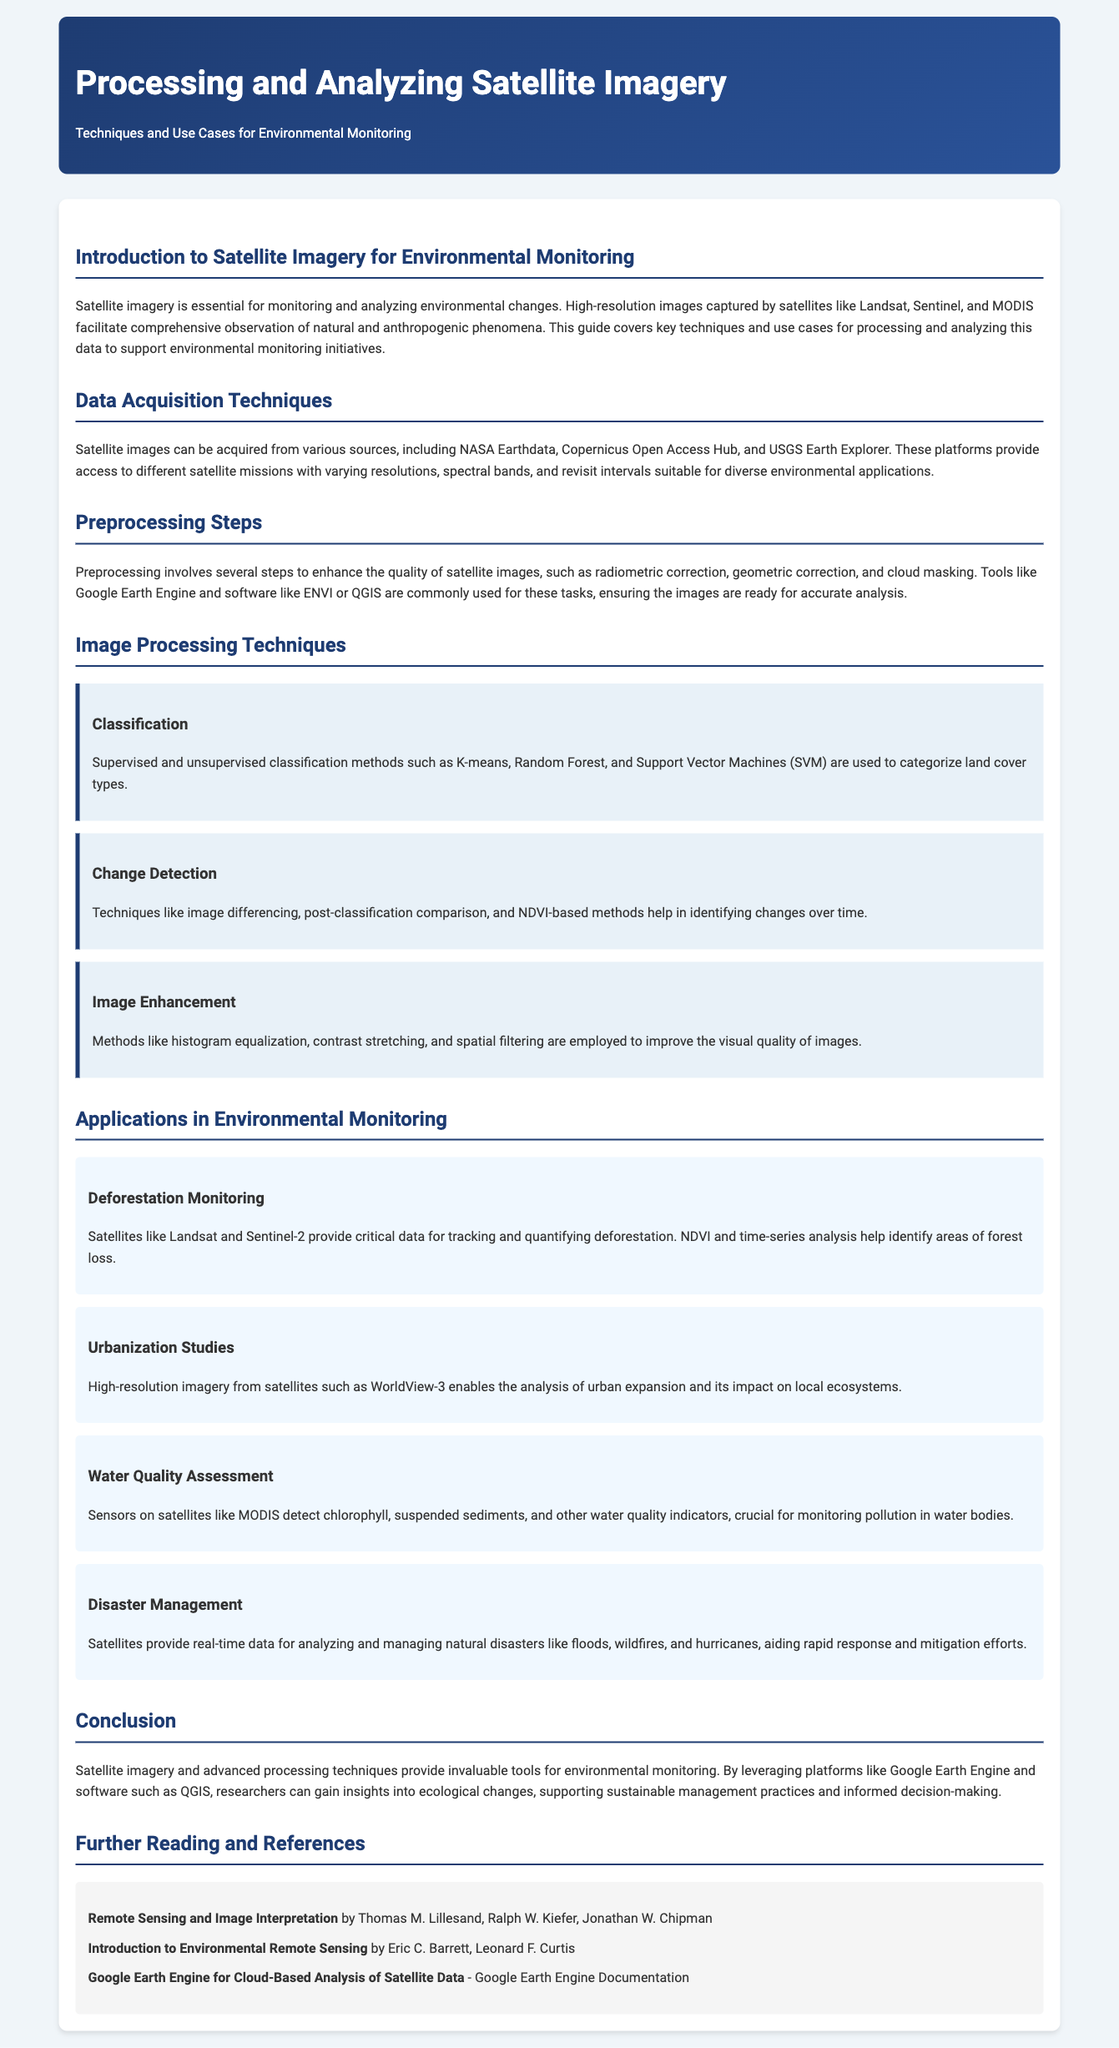What are the names of two satellite missions mentioned? The document states that satellite images can be acquired from missions including Landsat and Sentinel.
Answer: Landsat, Sentinel What is a preprocessing step that enhances satellite image quality? The document lists several preprocessing steps, one of which is radiometric correction.
Answer: Radiometric correction Which technique is used for monitoring deforestation? The document mentions NDVI and time-series analysis as methods to track deforestation.
Answer: NDVI and time-series analysis What is one application of satellite imagery in disaster management? The document states that satellites provide real-time data for analyzing natural disasters such as floods.
Answer: Floods Which software is mentioned for image processing? The guide lists tools like ENVI or QGIS for preprocessing satellite imagery.
Answer: ENVI or QGIS What type of classification methods are used for categorizing land cover types? The document refers to supervised and unsupervised classification methods such as K-means.
Answer: K-means What is one method mentioned for image enhancement? The document lists histogram equalization as a method to improve image quality.
Answer: Histogram equalization What kind of imagery is used for water quality assessment? The document states that MODIS detects indicators like chlorophyll for water quality analysis.
Answer: MODIS Which book is recommended for further reading? The guide suggests "Remote Sensing and Image Interpretation" as a further reading reference.
Answer: Remote Sensing and Image Interpretation 